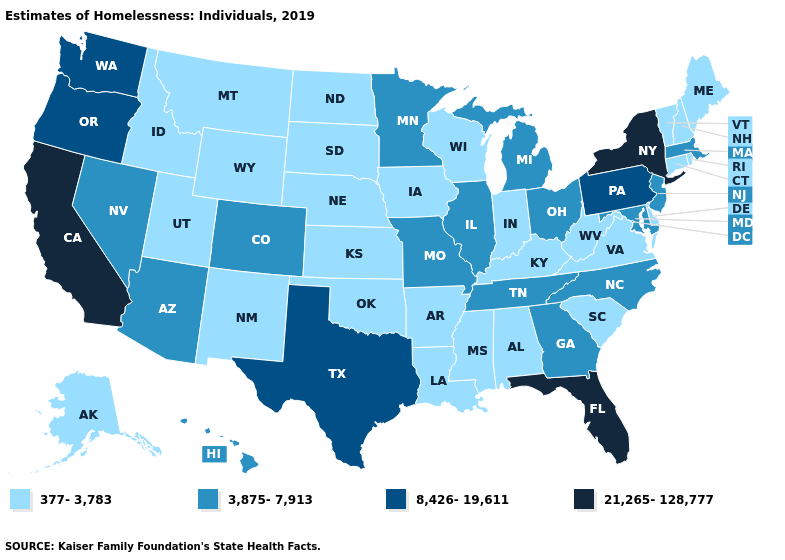Name the states that have a value in the range 377-3,783?
Keep it brief. Alabama, Alaska, Arkansas, Connecticut, Delaware, Idaho, Indiana, Iowa, Kansas, Kentucky, Louisiana, Maine, Mississippi, Montana, Nebraska, New Hampshire, New Mexico, North Dakota, Oklahoma, Rhode Island, South Carolina, South Dakota, Utah, Vermont, Virginia, West Virginia, Wisconsin, Wyoming. What is the value of Illinois?
Write a very short answer. 3,875-7,913. What is the highest value in the West ?
Answer briefly. 21,265-128,777. Which states have the highest value in the USA?
Concise answer only. California, Florida, New York. Name the states that have a value in the range 8,426-19,611?
Be succinct. Oregon, Pennsylvania, Texas, Washington. Does Missouri have the lowest value in the MidWest?
Short answer required. No. Name the states that have a value in the range 377-3,783?
Give a very brief answer. Alabama, Alaska, Arkansas, Connecticut, Delaware, Idaho, Indiana, Iowa, Kansas, Kentucky, Louisiana, Maine, Mississippi, Montana, Nebraska, New Hampshire, New Mexico, North Dakota, Oklahoma, Rhode Island, South Carolina, South Dakota, Utah, Vermont, Virginia, West Virginia, Wisconsin, Wyoming. Name the states that have a value in the range 377-3,783?
Be succinct. Alabama, Alaska, Arkansas, Connecticut, Delaware, Idaho, Indiana, Iowa, Kansas, Kentucky, Louisiana, Maine, Mississippi, Montana, Nebraska, New Hampshire, New Mexico, North Dakota, Oklahoma, Rhode Island, South Carolina, South Dakota, Utah, Vermont, Virginia, West Virginia, Wisconsin, Wyoming. What is the value of Nebraska?
Keep it brief. 377-3,783. What is the value of Mississippi?
Write a very short answer. 377-3,783. Does the map have missing data?
Quick response, please. No. What is the lowest value in states that border Arizona?
Write a very short answer. 377-3,783. Does New York have the highest value in the USA?
Keep it brief. Yes. What is the highest value in the USA?
Answer briefly. 21,265-128,777. Does Washington have a higher value than Mississippi?
Give a very brief answer. Yes. 